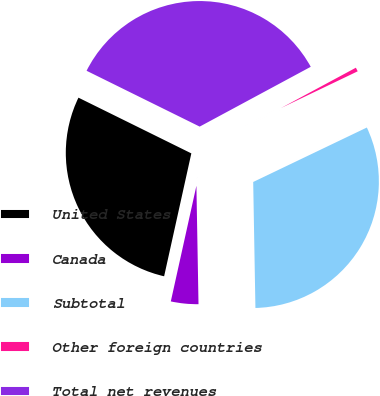<chart> <loc_0><loc_0><loc_500><loc_500><pie_chart><fcel>United States<fcel>Canada<fcel>Subtotal<fcel>Other foreign countries<fcel>Total net revenues<nl><fcel>28.83%<fcel>3.75%<fcel>31.83%<fcel>0.75%<fcel>34.84%<nl></chart> 